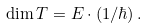Convert formula to latex. <formula><loc_0><loc_0><loc_500><loc_500>\dim T = E \cdot ( 1 / \hbar { ) } \, .</formula> 